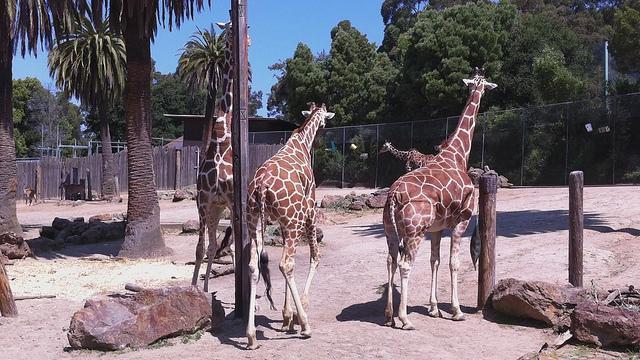How many giraffes?
Give a very brief answer. 4. How many giraffes can you see?
Give a very brief answer. 3. 